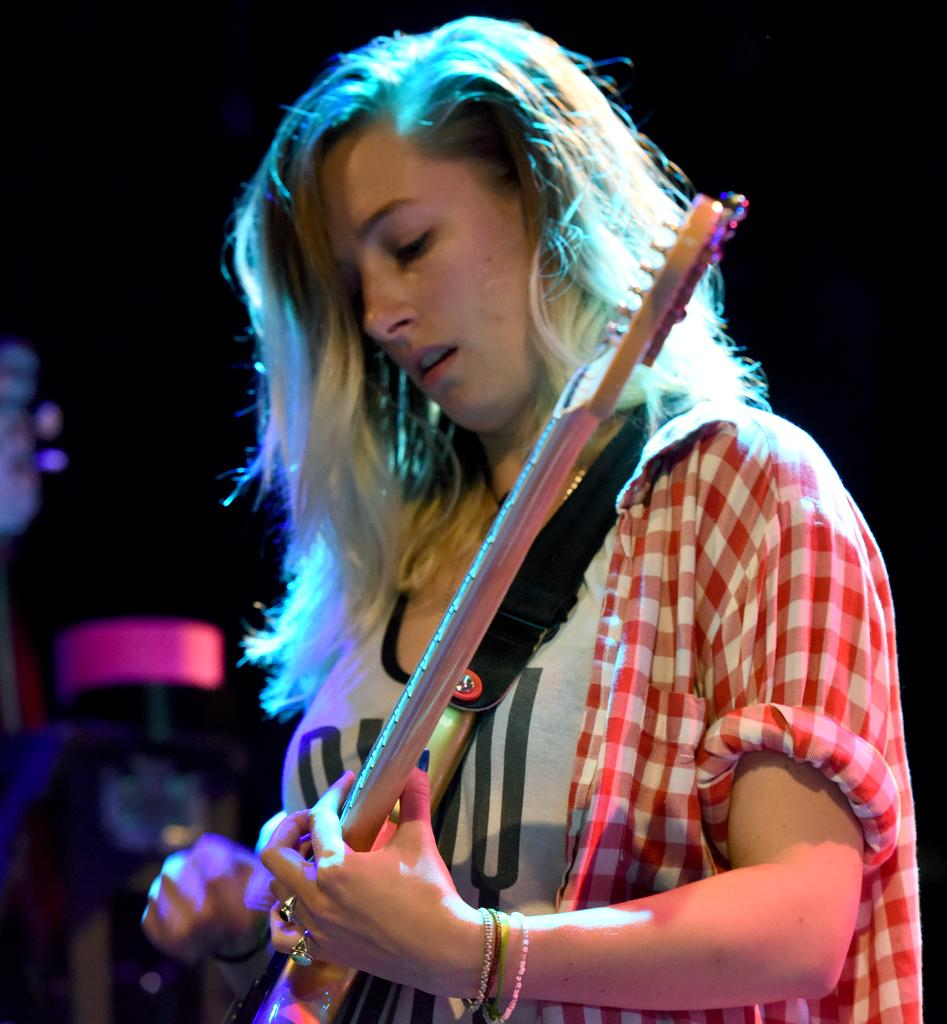Who is the main subject in the image? There is a lady in the image. Where is the lady positioned in the image? The lady is standing at the center of the image. What is the lady holding in her hands? The lady is holding a guitar in her hands. Can you describe any accessories the lady is wearing? The lady has four bangles on her left hand. What type of base is supporting the lady in the image? There is no base visible in the image, as the lady is standing on her own. 